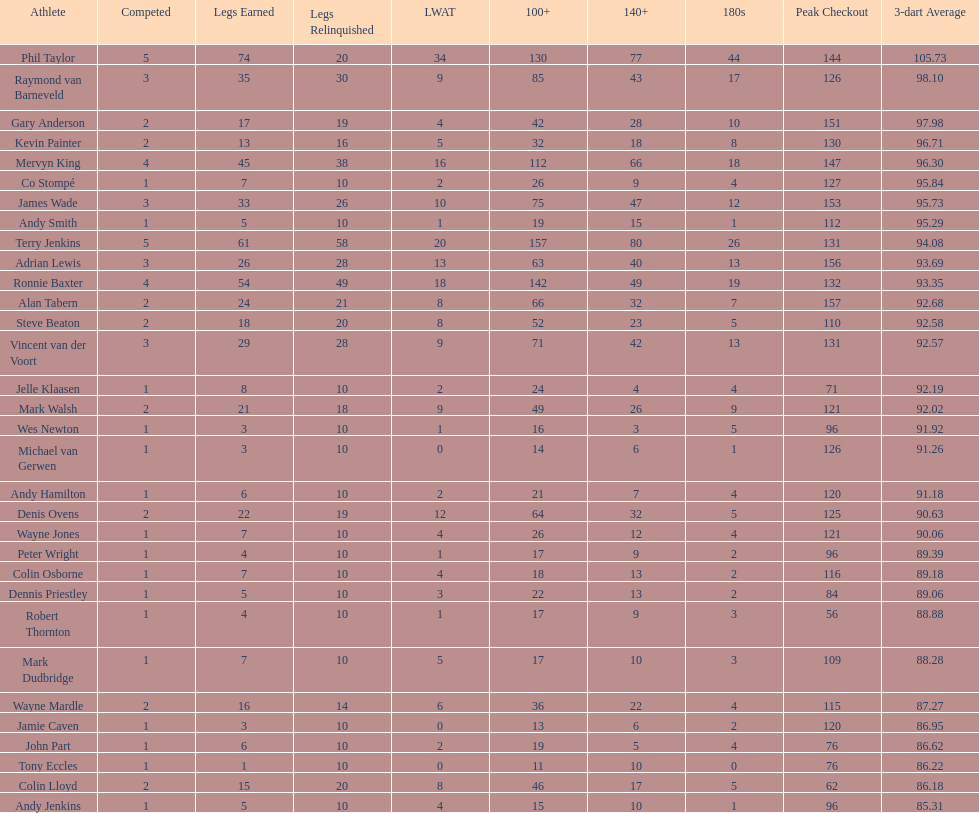Identify the players who have reached a high checkout of 13 Terry Jenkins, Vincent van der Voort. 